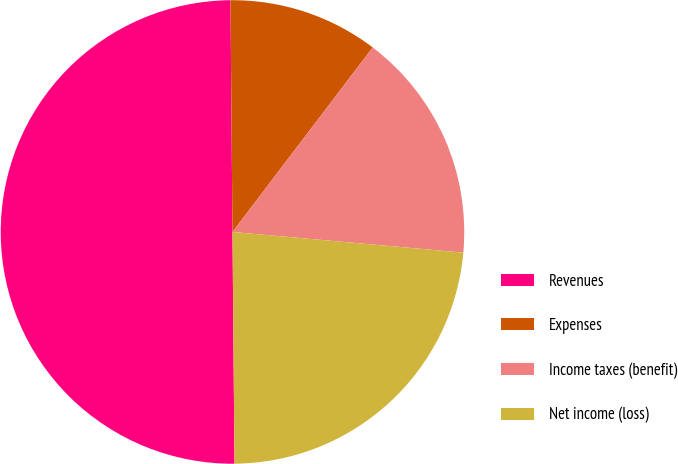Convert chart. <chart><loc_0><loc_0><loc_500><loc_500><pie_chart><fcel>Revenues<fcel>Expenses<fcel>Income taxes (benefit)<fcel>Net income (loss)<nl><fcel>50.0%<fcel>10.48%<fcel>16.08%<fcel>23.44%<nl></chart> 